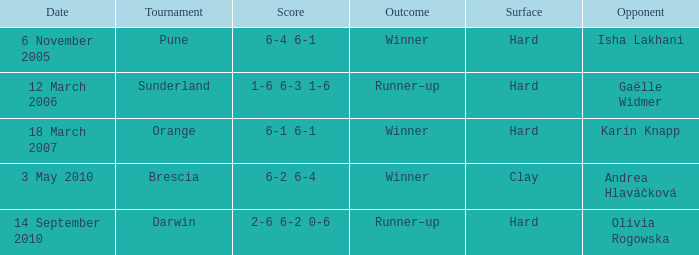What was the score of the tournament against Isha Lakhani? 6-4 6-1. 